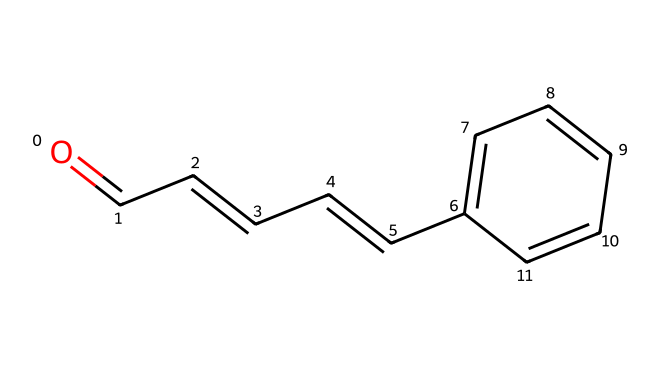What is the molecular formula of cinnamaldehyde? By analyzing the structure, we can count the number of carbon, hydrogen, and oxygen atoms present. There are 9 carbon atoms, 8 hydrogen atoms, and 1 oxygen atom, giving us the molecular formula C9H8O.
Answer: C9H8O How many double bonds are present in the structure? The structure indicates the presence of three double bonds. These can be observed between the carbon atoms and also between the carbon and oxygen (aldehyde group) and within the carbon chain.
Answer: 3 What type of functional group is found in cinnamaldehyde? The structure shows a carbonyl group (C=O) that characterizes aldehydes. This can be identified as the group containing the carbon atom double-bonded to oxygen and with at least one hydrogen atom attached directly to it.
Answer: aldehyde Which part of the structure contributes to the aromatic nature of cinnamaldehyde? The cyclic portion of the structure, which contains alternating double bonds, indicates that it has an aromatic ring. The presence of six carbon atoms arranged in a ring with delocalized electrons classifies it as aromatic.
Answer: aromatic ring What is the total number of rings in the chemical structure? Analyzing the structure shows only one cyclic arrangement that forms a benzene-like ring, meaning the total count of rings in the compound is one.
Answer: 1 How does the position of the double bond affect the properties of cinnamaldehyde? The double bond's presence between the first carbon atom and the aldehyde carbon can influence the reactivity and volatility of the compound, which is vital for aromatic compounds. This positioning contributes to the characteristic scent associated with cinnamon, enhancing both its chemical behavior and sensory properties.
Answer: enhances scent 